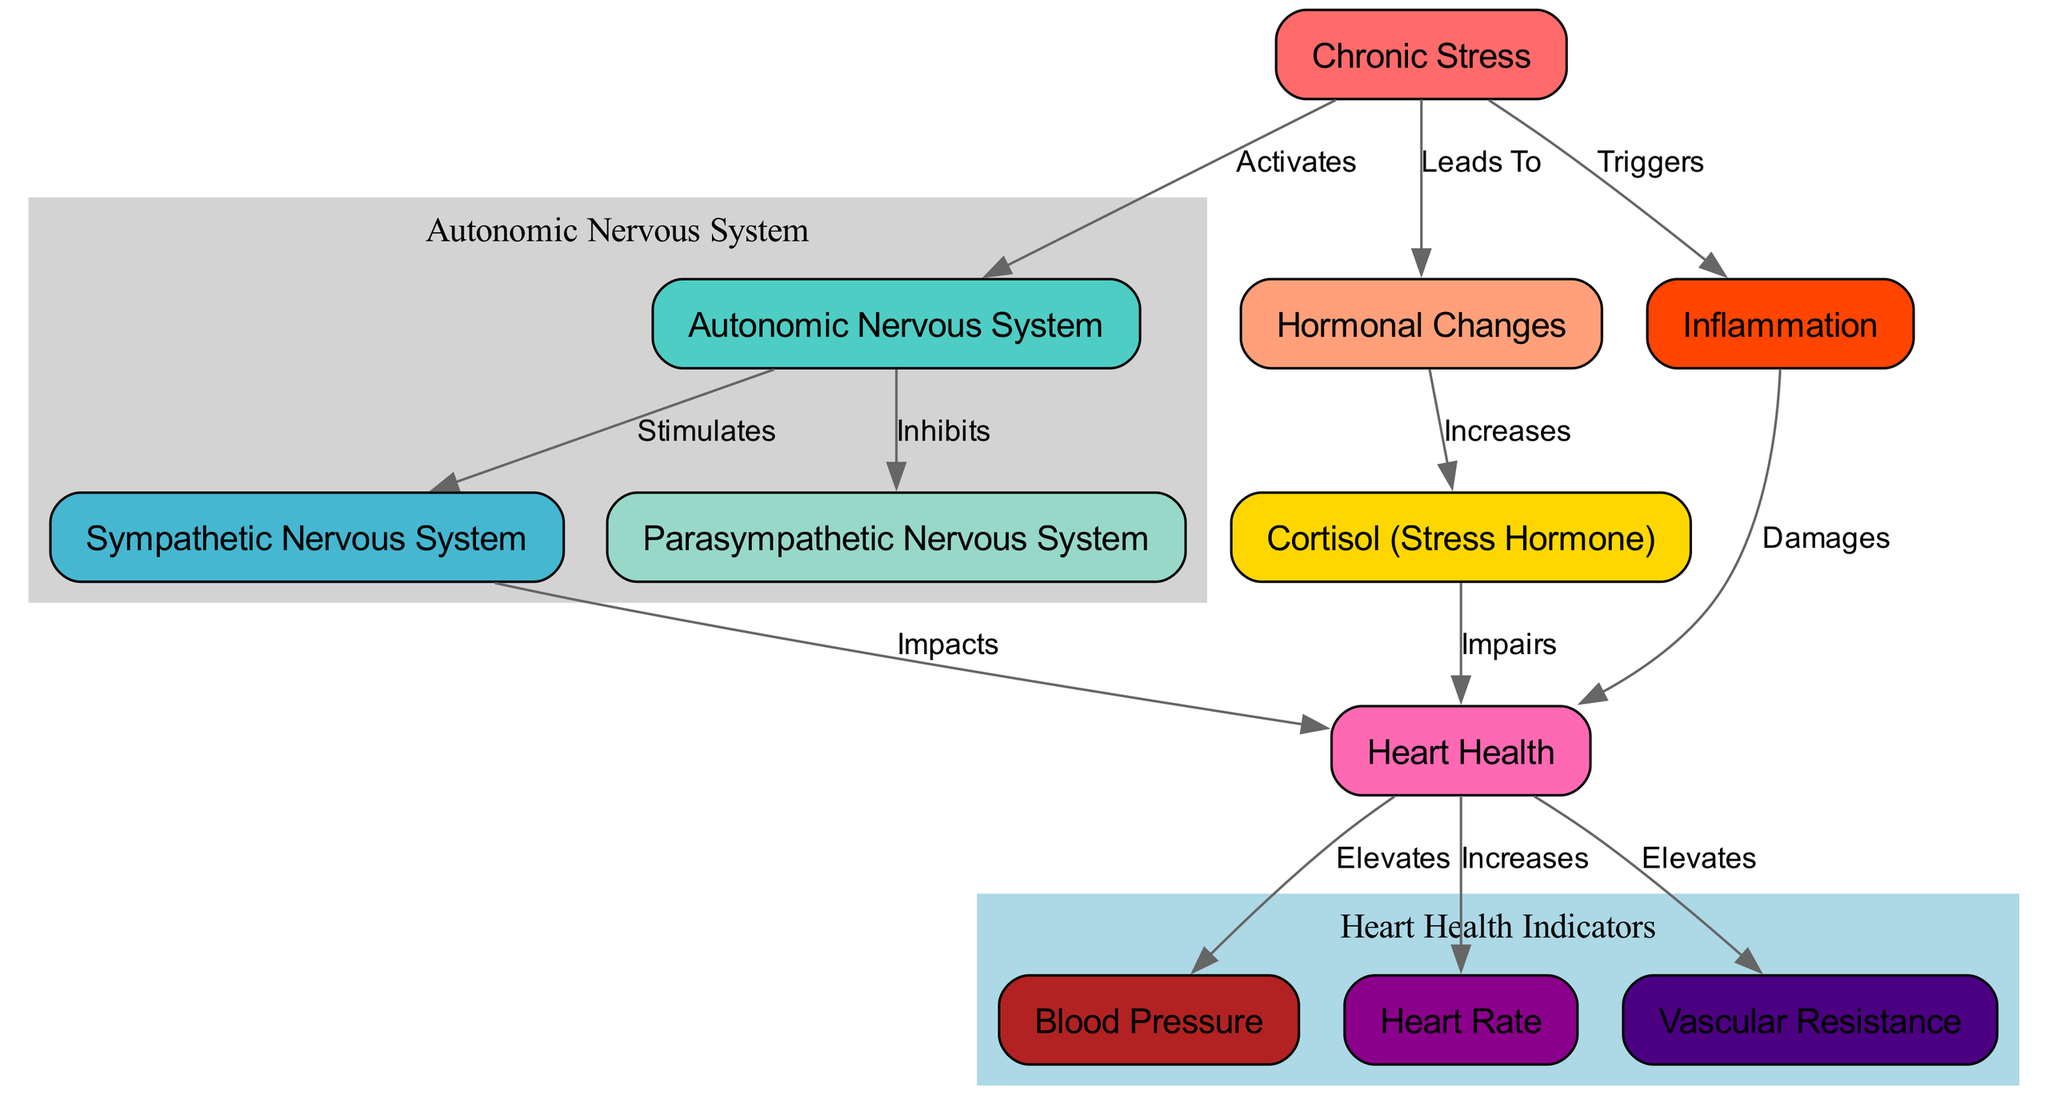What activates the autonomic nervous system? The diagram indicates that chronic stress activates the autonomic nervous system. This is the direct relationship depicted in the edges connecting the nodes.
Answer: Chronic Stress What hormone is increased due to hormonal changes? According to the diagram, hormonal changes result in an increase of cortisol, the stress hormone, which is explicitly stated in the edge relationship.
Answer: Cortisol How many nodes are there in total? By counting the unique entities in the diagram's nodes section, it is shown that there are 11 nodes present.
Answer: 11 What effect does cortisol have on heart health? The diagram clearly states that cortisol impairs heart health, indicating a detrimental effect as shown in the connection between these two nodes.
Answer: Impairs What is the relationship between inflammation and heart health? The diagram specifies that inflammation damages heart health, illustrating that inflammation negatively impacts heart function as indicated in the connection between the respective nodes.
Answer: Damages What are the three indicators of heart health shown in the diagram? The diagram explicitly lists three indicators related to heart health: blood pressure, heart rate, and vascular resistance, each being a distinct node connected to heart health.
Answer: Blood Pressure, Heart Rate, Vascular Resistance Which system is inhibited by chronic stress? The diagram shows that the autonomic nervous system is inhibited by chronic stress, illustrated by the edge labeling between these two nodes.
Answer: Parasympathetic Nervous System What triggers inflammation? In the diagram, chronic stress is indicated as the trigger for inflammation, reflected in the direct connection from chronic stress to inflammation.
Answer: Chronic Stress What is the effect of the sympathetic nervous system on heart health? The diagram illustrates that the sympathetic nervous system impacts heart health, which shows that this branch of the autonomic nervous system plays a role in cardiovascular health as indicated in the edge connection.
Answer: Impacts 